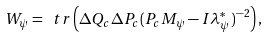Convert formula to latex. <formula><loc_0><loc_0><loc_500><loc_500>W _ { \psi } = \ t r \left ( \Delta Q _ { c } \Delta P _ { c } ( P _ { c } M _ { \psi } - I \lambda _ { \psi } ^ { \ast } ) ^ { - 2 } \right ) ,</formula> 